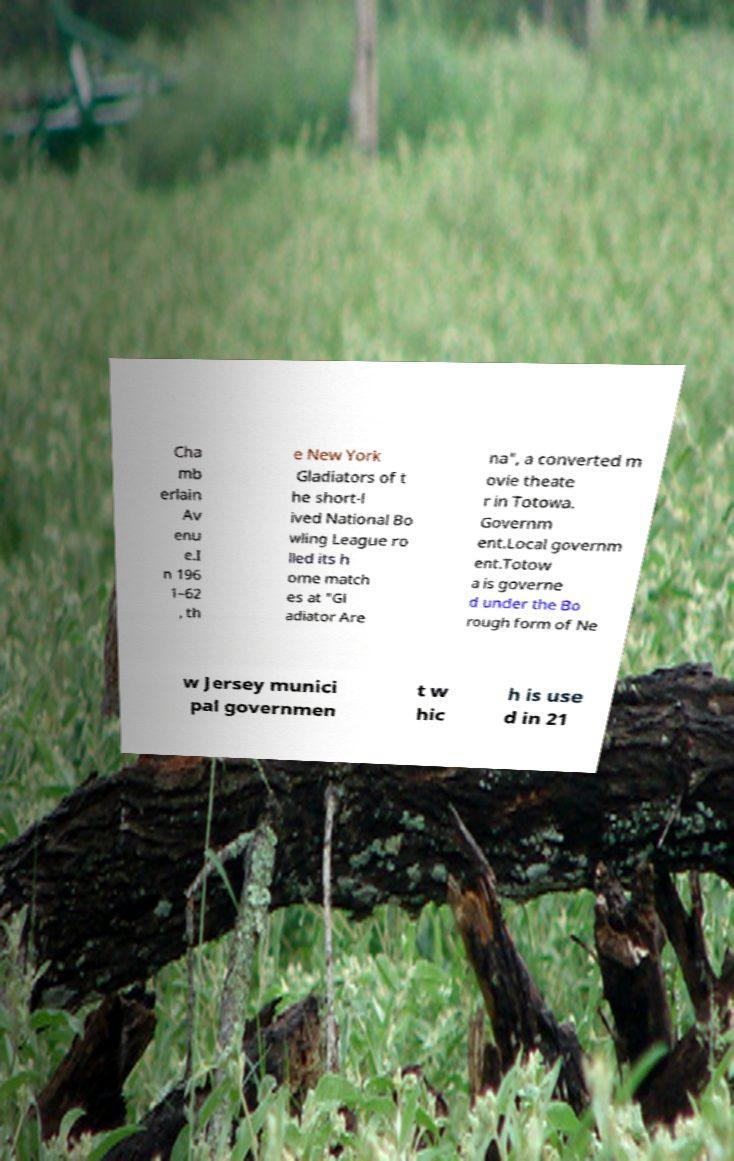Please identify and transcribe the text found in this image. Cha mb erlain Av enu e.I n 196 1–62 , th e New York Gladiators of t he short-l ived National Bo wling League ro lled its h ome match es at "Gl adiator Are na", a converted m ovie theate r in Totowa. Governm ent.Local governm ent.Totow a is governe d under the Bo rough form of Ne w Jersey munici pal governmen t w hic h is use d in 21 